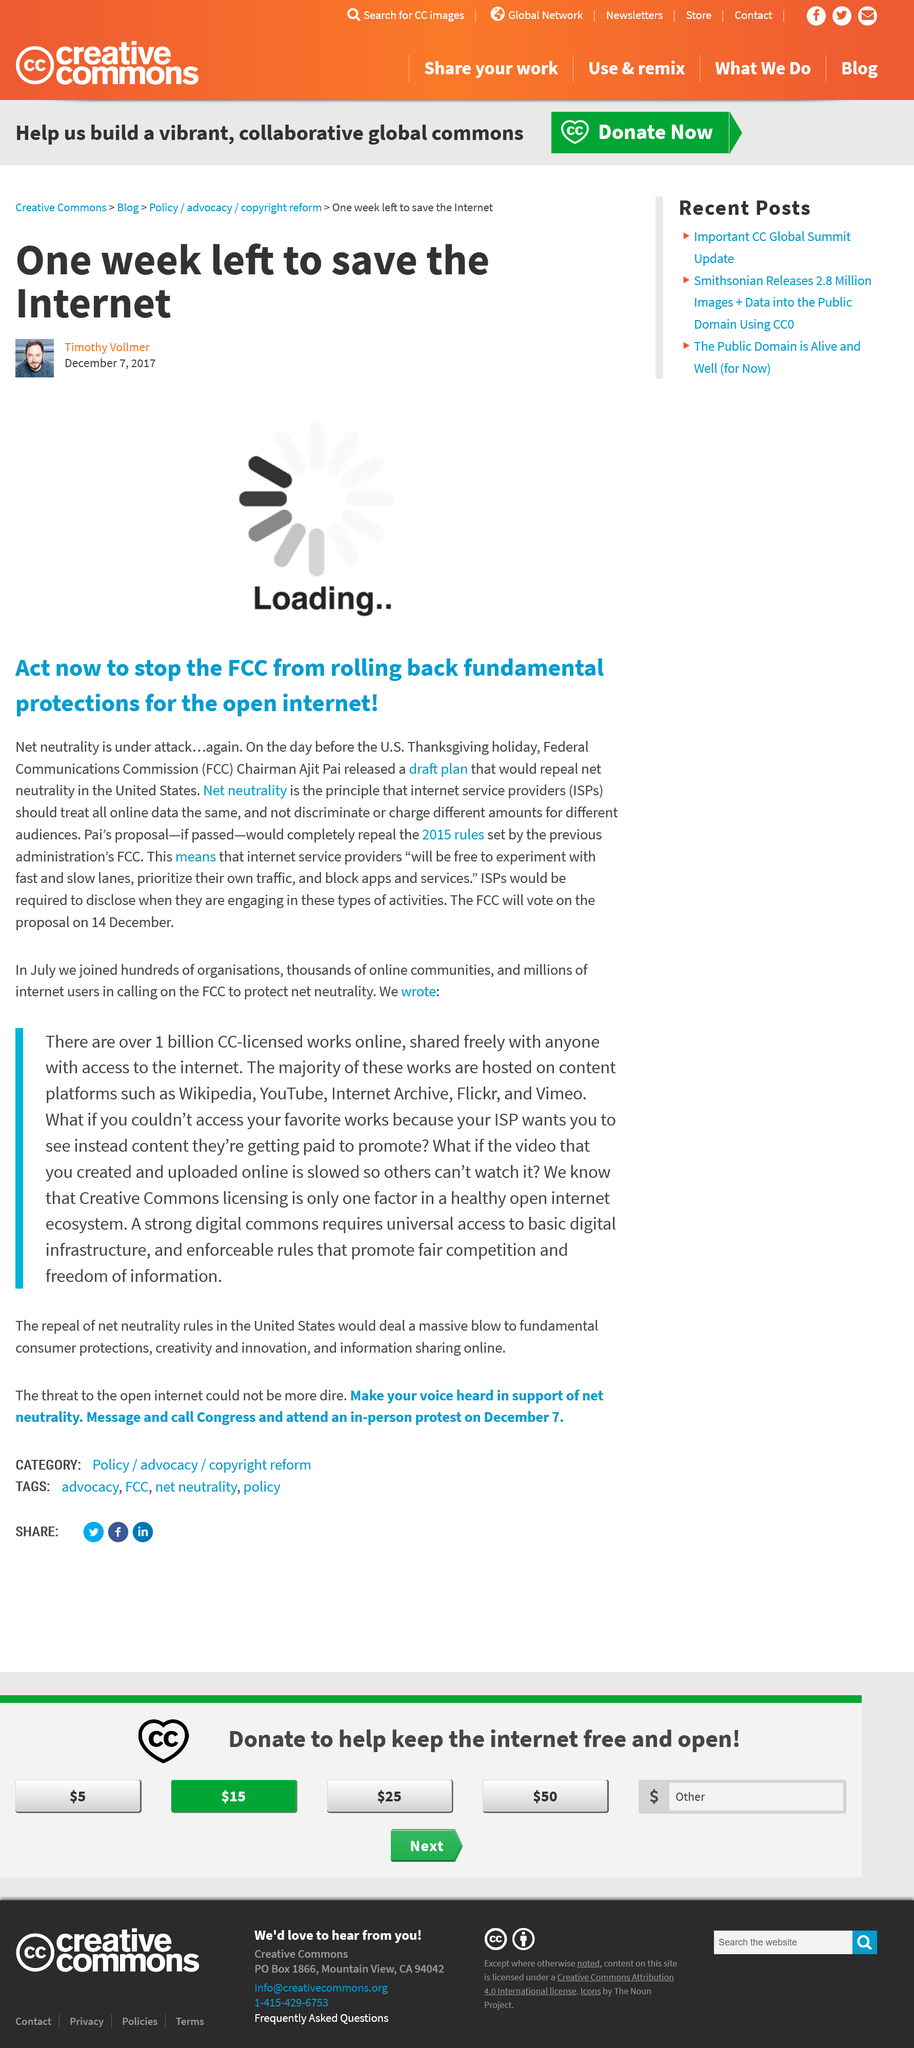Outline some significant characteristics in this image. The Federal Communications Commission (FCC) is a government agency responsible for regulating communication services and networks in the United States. The FCC is an independent agency, meaning it operates at arm's length from the executive and legislative branches of the federal government. Its primary mission is to manage the nation's radio, television, wire, satellite, and cable communications so that all Americans may have access to reliable, affordable, and diverse sources of information and entertainment. The Federal Communications Commission (FCC) will vote on the Net Neutrality proposal on December 14th. Ajit Pai is the current Chairman of the Federal Communications Commission (FCC). 